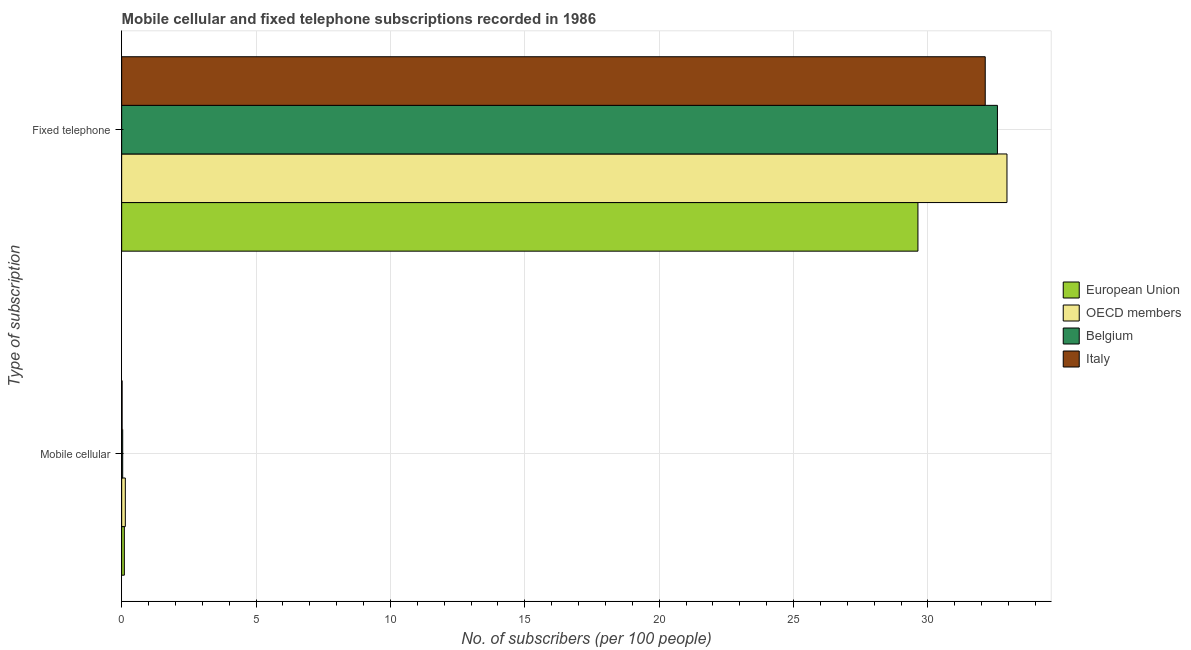How many bars are there on the 2nd tick from the top?
Make the answer very short. 4. What is the label of the 2nd group of bars from the top?
Give a very brief answer. Mobile cellular. What is the number of fixed telephone subscribers in Italy?
Your response must be concise. 32.13. Across all countries, what is the maximum number of mobile cellular subscribers?
Offer a terse response. 0.14. Across all countries, what is the minimum number of mobile cellular subscribers?
Your answer should be very brief. 0.02. In which country was the number of mobile cellular subscribers maximum?
Provide a succinct answer. OECD members. In which country was the number of mobile cellular subscribers minimum?
Your answer should be very brief. Italy. What is the total number of fixed telephone subscribers in the graph?
Your answer should be very brief. 127.28. What is the difference between the number of mobile cellular subscribers in OECD members and that in Italy?
Keep it short and to the point. 0.12. What is the difference between the number of fixed telephone subscribers in OECD members and the number of mobile cellular subscribers in European Union?
Your answer should be very brief. 32.84. What is the average number of mobile cellular subscribers per country?
Offer a terse response. 0.07. What is the difference between the number of mobile cellular subscribers and number of fixed telephone subscribers in OECD members?
Ensure brevity in your answer.  -32.8. In how many countries, is the number of fixed telephone subscribers greater than 1 ?
Your response must be concise. 4. What is the ratio of the number of fixed telephone subscribers in OECD members to that in European Union?
Make the answer very short. 1.11. In how many countries, is the number of mobile cellular subscribers greater than the average number of mobile cellular subscribers taken over all countries?
Your answer should be compact. 2. What does the 1st bar from the top in Mobile cellular represents?
Keep it short and to the point. Italy. How many bars are there?
Provide a succinct answer. 8. Are all the bars in the graph horizontal?
Offer a very short reply. Yes. How many countries are there in the graph?
Give a very brief answer. 4. Are the values on the major ticks of X-axis written in scientific E-notation?
Offer a terse response. No. Does the graph contain grids?
Your answer should be very brief. Yes. Where does the legend appear in the graph?
Your response must be concise. Center right. What is the title of the graph?
Provide a short and direct response. Mobile cellular and fixed telephone subscriptions recorded in 1986. What is the label or title of the X-axis?
Your answer should be compact. No. of subscribers (per 100 people). What is the label or title of the Y-axis?
Provide a succinct answer. Type of subscription. What is the No. of subscribers (per 100 people) of European Union in Mobile cellular?
Your answer should be very brief. 0.1. What is the No. of subscribers (per 100 people) in OECD members in Mobile cellular?
Your answer should be compact. 0.14. What is the No. of subscribers (per 100 people) in Belgium in Mobile cellular?
Ensure brevity in your answer.  0.04. What is the No. of subscribers (per 100 people) in Italy in Mobile cellular?
Ensure brevity in your answer.  0.02. What is the No. of subscribers (per 100 people) in European Union in Fixed telephone?
Provide a short and direct response. 29.63. What is the No. of subscribers (per 100 people) in OECD members in Fixed telephone?
Offer a terse response. 32.94. What is the No. of subscribers (per 100 people) in Belgium in Fixed telephone?
Offer a terse response. 32.58. What is the No. of subscribers (per 100 people) of Italy in Fixed telephone?
Your answer should be very brief. 32.13. Across all Type of subscription, what is the maximum No. of subscribers (per 100 people) in European Union?
Your response must be concise. 29.63. Across all Type of subscription, what is the maximum No. of subscribers (per 100 people) of OECD members?
Provide a short and direct response. 32.94. Across all Type of subscription, what is the maximum No. of subscribers (per 100 people) in Belgium?
Provide a short and direct response. 32.58. Across all Type of subscription, what is the maximum No. of subscribers (per 100 people) in Italy?
Give a very brief answer. 32.13. Across all Type of subscription, what is the minimum No. of subscribers (per 100 people) of European Union?
Provide a succinct answer. 0.1. Across all Type of subscription, what is the minimum No. of subscribers (per 100 people) in OECD members?
Offer a very short reply. 0.14. Across all Type of subscription, what is the minimum No. of subscribers (per 100 people) in Belgium?
Make the answer very short. 0.04. Across all Type of subscription, what is the minimum No. of subscribers (per 100 people) of Italy?
Your response must be concise. 0.02. What is the total No. of subscribers (per 100 people) of European Union in the graph?
Give a very brief answer. 29.73. What is the total No. of subscribers (per 100 people) in OECD members in the graph?
Offer a terse response. 33.08. What is the total No. of subscribers (per 100 people) of Belgium in the graph?
Provide a short and direct response. 32.62. What is the total No. of subscribers (per 100 people) in Italy in the graph?
Your answer should be compact. 32.15. What is the difference between the No. of subscribers (per 100 people) of European Union in Mobile cellular and that in Fixed telephone?
Your answer should be very brief. -29.53. What is the difference between the No. of subscribers (per 100 people) of OECD members in Mobile cellular and that in Fixed telephone?
Provide a short and direct response. -32.8. What is the difference between the No. of subscribers (per 100 people) of Belgium in Mobile cellular and that in Fixed telephone?
Your response must be concise. -32.55. What is the difference between the No. of subscribers (per 100 people) in Italy in Mobile cellular and that in Fixed telephone?
Keep it short and to the point. -32.11. What is the difference between the No. of subscribers (per 100 people) in European Union in Mobile cellular and the No. of subscribers (per 100 people) in OECD members in Fixed telephone?
Offer a very short reply. -32.84. What is the difference between the No. of subscribers (per 100 people) of European Union in Mobile cellular and the No. of subscribers (per 100 people) of Belgium in Fixed telephone?
Provide a short and direct response. -32.49. What is the difference between the No. of subscribers (per 100 people) in European Union in Mobile cellular and the No. of subscribers (per 100 people) in Italy in Fixed telephone?
Keep it short and to the point. -32.03. What is the difference between the No. of subscribers (per 100 people) of OECD members in Mobile cellular and the No. of subscribers (per 100 people) of Belgium in Fixed telephone?
Your response must be concise. -32.45. What is the difference between the No. of subscribers (per 100 people) of OECD members in Mobile cellular and the No. of subscribers (per 100 people) of Italy in Fixed telephone?
Offer a very short reply. -31.99. What is the difference between the No. of subscribers (per 100 people) in Belgium in Mobile cellular and the No. of subscribers (per 100 people) in Italy in Fixed telephone?
Your answer should be compact. -32.09. What is the average No. of subscribers (per 100 people) of European Union per Type of subscription?
Give a very brief answer. 14.86. What is the average No. of subscribers (per 100 people) in OECD members per Type of subscription?
Your response must be concise. 16.54. What is the average No. of subscribers (per 100 people) of Belgium per Type of subscription?
Provide a succinct answer. 16.31. What is the average No. of subscribers (per 100 people) in Italy per Type of subscription?
Give a very brief answer. 16.07. What is the difference between the No. of subscribers (per 100 people) in European Union and No. of subscribers (per 100 people) in OECD members in Mobile cellular?
Offer a very short reply. -0.04. What is the difference between the No. of subscribers (per 100 people) in European Union and No. of subscribers (per 100 people) in Belgium in Mobile cellular?
Provide a short and direct response. 0.06. What is the difference between the No. of subscribers (per 100 people) in European Union and No. of subscribers (per 100 people) in Italy in Mobile cellular?
Offer a terse response. 0.08. What is the difference between the No. of subscribers (per 100 people) of OECD members and No. of subscribers (per 100 people) of Belgium in Mobile cellular?
Make the answer very short. 0.1. What is the difference between the No. of subscribers (per 100 people) of OECD members and No. of subscribers (per 100 people) of Italy in Mobile cellular?
Provide a short and direct response. 0.12. What is the difference between the No. of subscribers (per 100 people) of Belgium and No. of subscribers (per 100 people) of Italy in Mobile cellular?
Provide a short and direct response. 0.02. What is the difference between the No. of subscribers (per 100 people) in European Union and No. of subscribers (per 100 people) in OECD members in Fixed telephone?
Give a very brief answer. -3.31. What is the difference between the No. of subscribers (per 100 people) of European Union and No. of subscribers (per 100 people) of Belgium in Fixed telephone?
Keep it short and to the point. -2.96. What is the difference between the No. of subscribers (per 100 people) in European Union and No. of subscribers (per 100 people) in Italy in Fixed telephone?
Give a very brief answer. -2.5. What is the difference between the No. of subscribers (per 100 people) in OECD members and No. of subscribers (per 100 people) in Belgium in Fixed telephone?
Your answer should be very brief. 0.35. What is the difference between the No. of subscribers (per 100 people) in OECD members and No. of subscribers (per 100 people) in Italy in Fixed telephone?
Offer a terse response. 0.81. What is the difference between the No. of subscribers (per 100 people) of Belgium and No. of subscribers (per 100 people) of Italy in Fixed telephone?
Keep it short and to the point. 0.45. What is the ratio of the No. of subscribers (per 100 people) in European Union in Mobile cellular to that in Fixed telephone?
Keep it short and to the point. 0. What is the ratio of the No. of subscribers (per 100 people) of OECD members in Mobile cellular to that in Fixed telephone?
Provide a short and direct response. 0. What is the ratio of the No. of subscribers (per 100 people) of Belgium in Mobile cellular to that in Fixed telephone?
Keep it short and to the point. 0. What is the ratio of the No. of subscribers (per 100 people) of Italy in Mobile cellular to that in Fixed telephone?
Ensure brevity in your answer.  0. What is the difference between the highest and the second highest No. of subscribers (per 100 people) in European Union?
Provide a short and direct response. 29.53. What is the difference between the highest and the second highest No. of subscribers (per 100 people) of OECD members?
Make the answer very short. 32.8. What is the difference between the highest and the second highest No. of subscribers (per 100 people) in Belgium?
Your answer should be very brief. 32.55. What is the difference between the highest and the second highest No. of subscribers (per 100 people) in Italy?
Provide a succinct answer. 32.11. What is the difference between the highest and the lowest No. of subscribers (per 100 people) in European Union?
Your response must be concise. 29.53. What is the difference between the highest and the lowest No. of subscribers (per 100 people) in OECD members?
Offer a very short reply. 32.8. What is the difference between the highest and the lowest No. of subscribers (per 100 people) of Belgium?
Your answer should be very brief. 32.55. What is the difference between the highest and the lowest No. of subscribers (per 100 people) in Italy?
Offer a terse response. 32.11. 